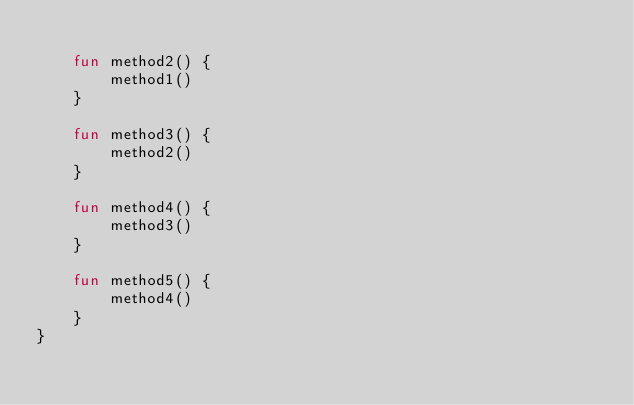Convert code to text. <code><loc_0><loc_0><loc_500><loc_500><_Kotlin_>
    fun method2() {
        method1()
    }

    fun method3() {
        method2()
    }

    fun method4() {
        method3()
    }

    fun method5() {
        method4()
    }
}
</code> 